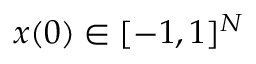Convert formula to latex. <formula><loc_0><loc_0><loc_500><loc_500>x ( 0 ) \in [ - 1 , 1 ] ^ { N }</formula> 